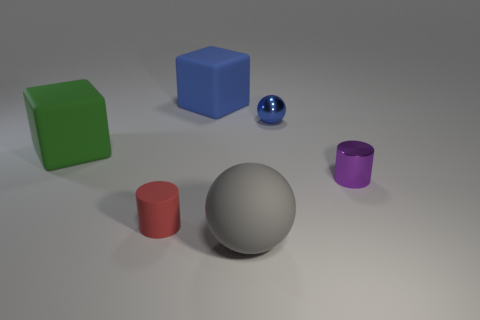Add 3 blue cubes. How many objects exist? 9 Subtract all cyan spheres. Subtract all green cubes. How many spheres are left? 2 Subtract all cubes. How many objects are left? 4 Add 1 metal spheres. How many metal spheres exist? 2 Subtract 0 brown cylinders. How many objects are left? 6 Subtract all tiny brown matte cylinders. Subtract all purple metal cylinders. How many objects are left? 5 Add 3 blue metallic spheres. How many blue metallic spheres are left? 4 